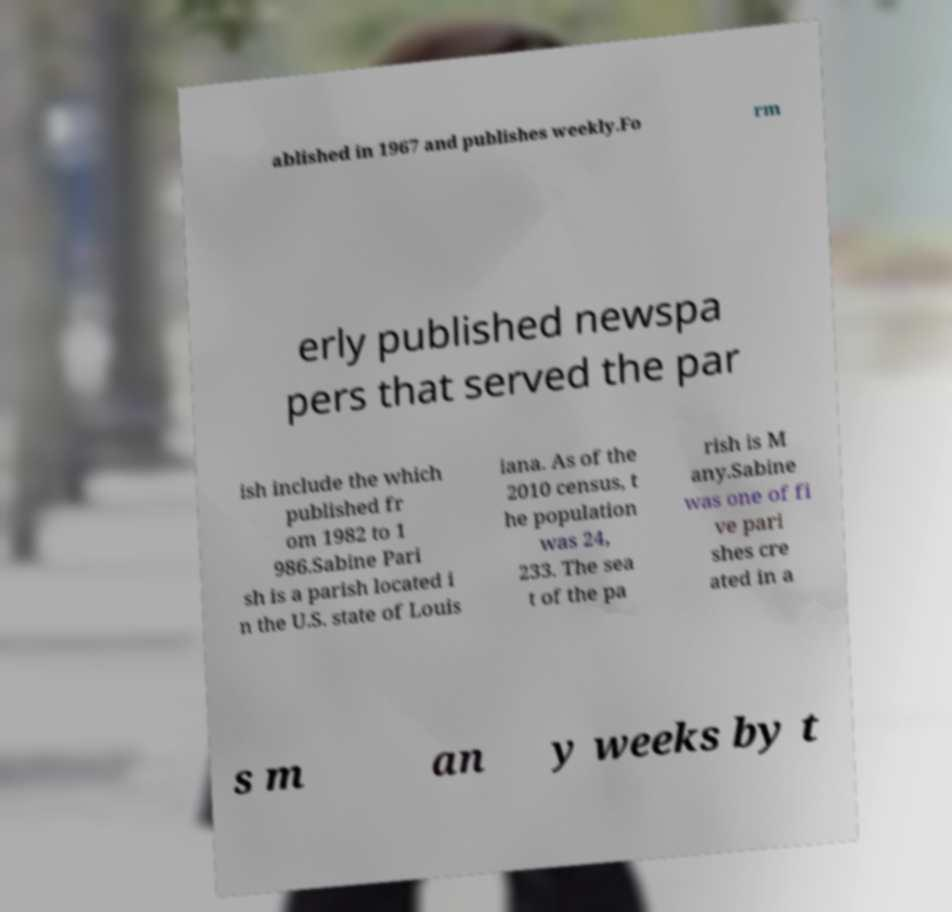Can you accurately transcribe the text from the provided image for me? ablished in 1967 and publishes weekly.Fo rm erly published newspa pers that served the par ish include the which published fr om 1982 to 1 986.Sabine Pari sh is a parish located i n the U.S. state of Louis iana. As of the 2010 census, t he population was 24, 233. The sea t of the pa rish is M any.Sabine was one of fi ve pari shes cre ated in a s m an y weeks by t 